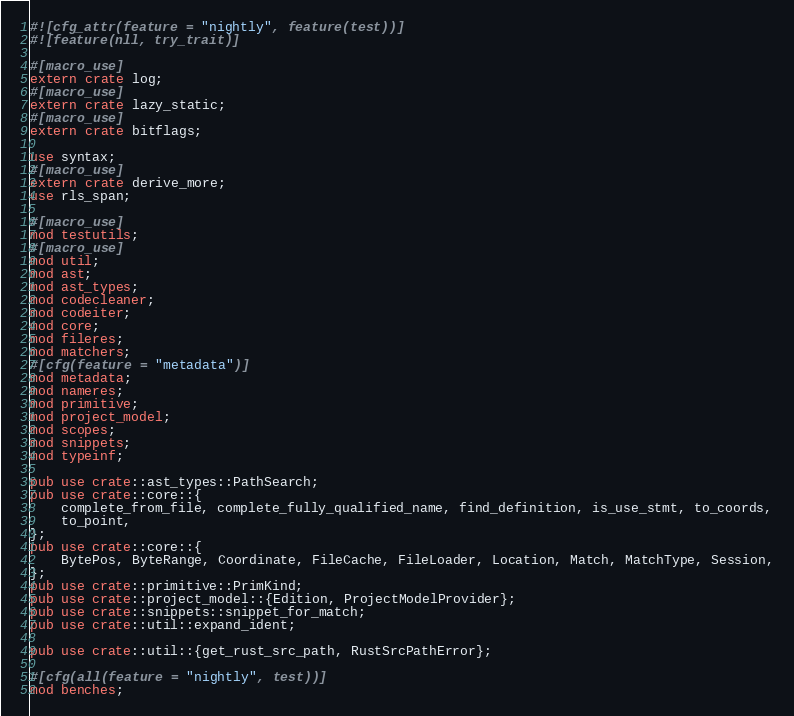Convert code to text. <code><loc_0><loc_0><loc_500><loc_500><_Rust_>#![cfg_attr(feature = "nightly", feature(test))]
#![feature(nll, try_trait)]

#[macro_use]
extern crate log;
#[macro_use]
extern crate lazy_static;
#[macro_use]
extern crate bitflags;

use syntax;
#[macro_use]
extern crate derive_more;
use rls_span;

#[macro_use]
mod testutils;
#[macro_use]
mod util;
mod ast;
mod ast_types;
mod codecleaner;
mod codeiter;
mod core;
mod fileres;
mod matchers;
#[cfg(feature = "metadata")]
mod metadata;
mod nameres;
mod primitive;
mod project_model;
mod scopes;
mod snippets;
mod typeinf;

pub use crate::ast_types::PathSearch;
pub use crate::core::{
    complete_from_file, complete_fully_qualified_name, find_definition, is_use_stmt, to_coords,
    to_point,
};
pub use crate::core::{
    BytePos, ByteRange, Coordinate, FileCache, FileLoader, Location, Match, MatchType, Session,
};
pub use crate::primitive::PrimKind;
pub use crate::project_model::{Edition, ProjectModelProvider};
pub use crate::snippets::snippet_for_match;
pub use crate::util::expand_ident;

pub use crate::util::{get_rust_src_path, RustSrcPathError};

#[cfg(all(feature = "nightly", test))]
mod benches;
</code> 